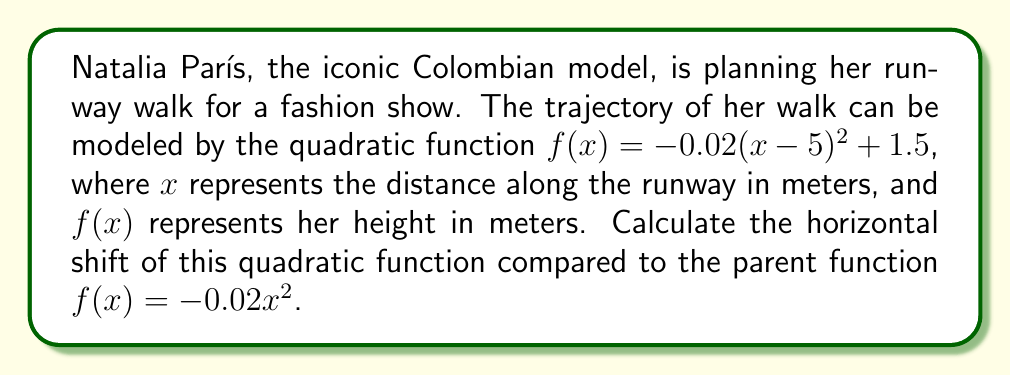Show me your answer to this math problem. To find the horizontal shift of a quadratic function, we need to compare it to its parent function. The general form of a quadratic function with a horizontal shift is:

$$f(x) = a(x - h)^2 + k$$

where $h$ represents the horizontal shift.

In this case, we have:

$$f(x) = -0.02(x-5)^2 + 1.5$$

Comparing this to the general form, we can see that:

1. $a = -0.02$ (which matches the parent function)
2. $h = 5$
3. $k = 1.5$ (vertical shift, not relevant for this question)

The horizontal shift is represented by $h$, which is 5 in this case.

A positive value of $h$ indicates a shift to the right. This means Natalia's runway walk trajectory is shifted 5 meters to the right compared to the parent function.
Answer: The horizontal shift is 5 meters to the right. 